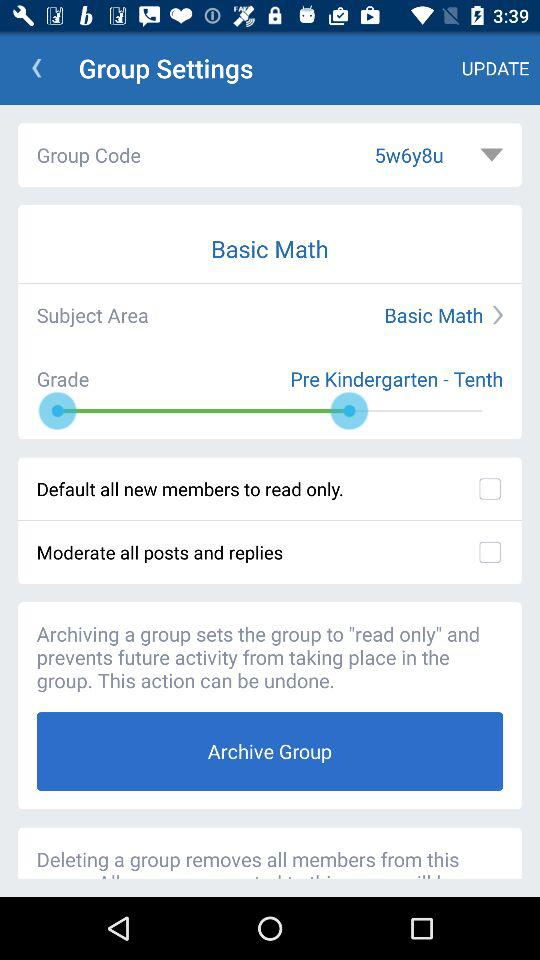What's the selected option for the group code? The selected option for the group code is "5w6y8u". 